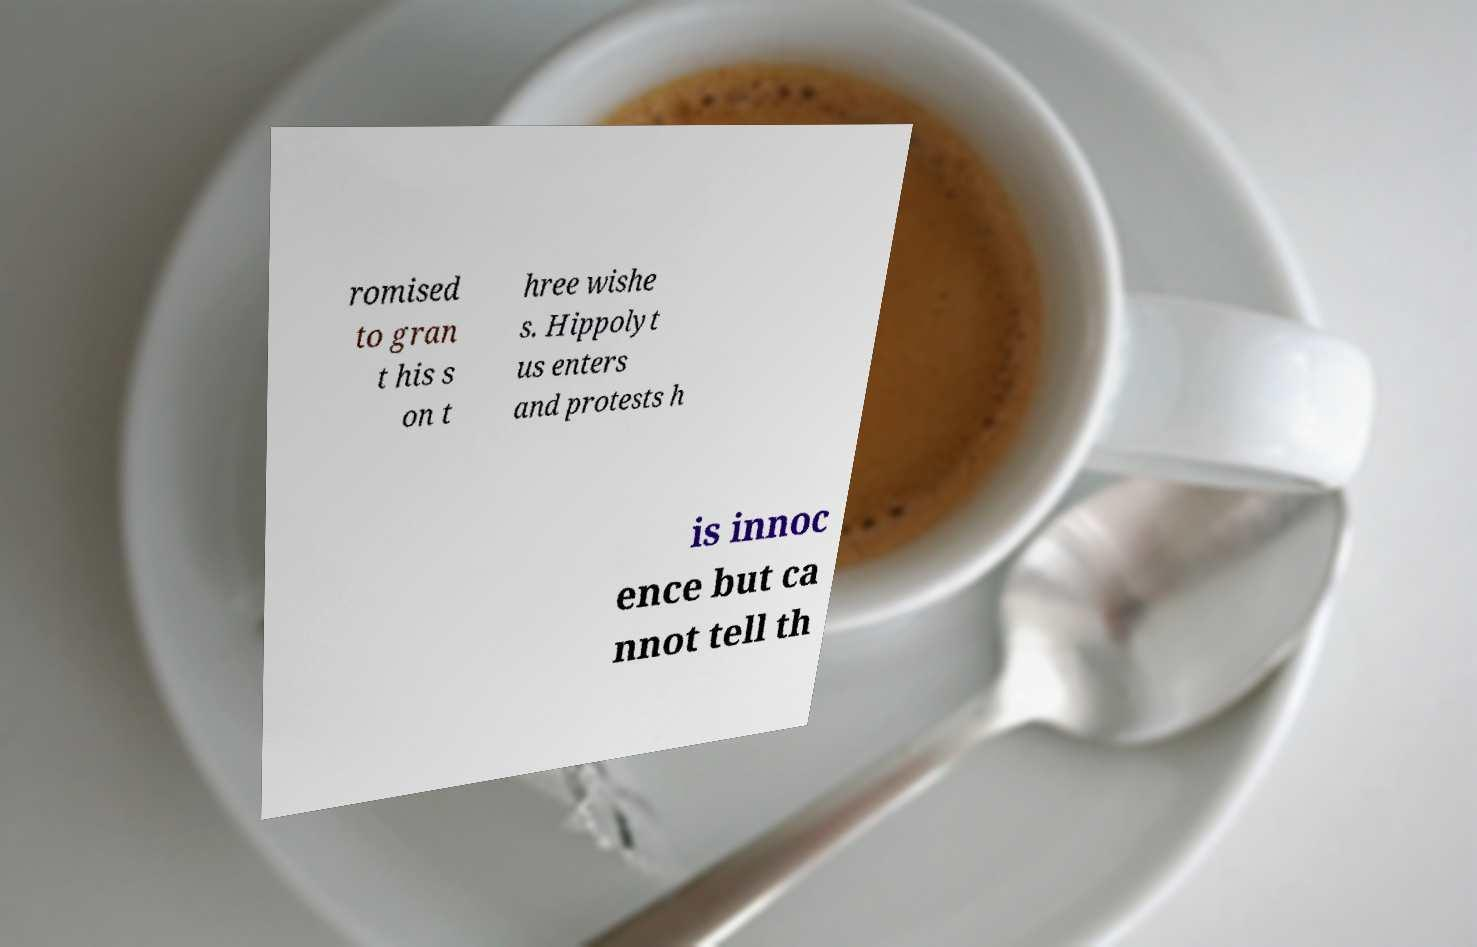Can you read and provide the text displayed in the image?This photo seems to have some interesting text. Can you extract and type it out for me? romised to gran t his s on t hree wishe s. Hippolyt us enters and protests h is innoc ence but ca nnot tell th 